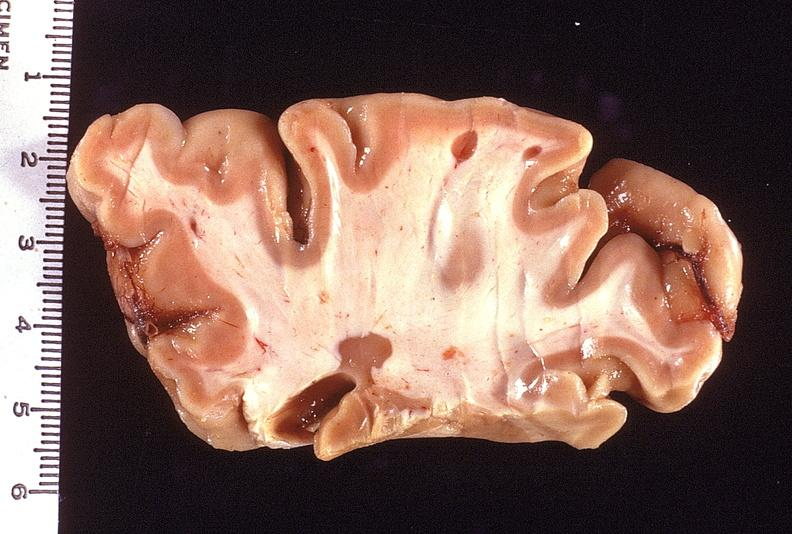s lesion in dome of uterus present?
Answer the question using a single word or phrase. No 